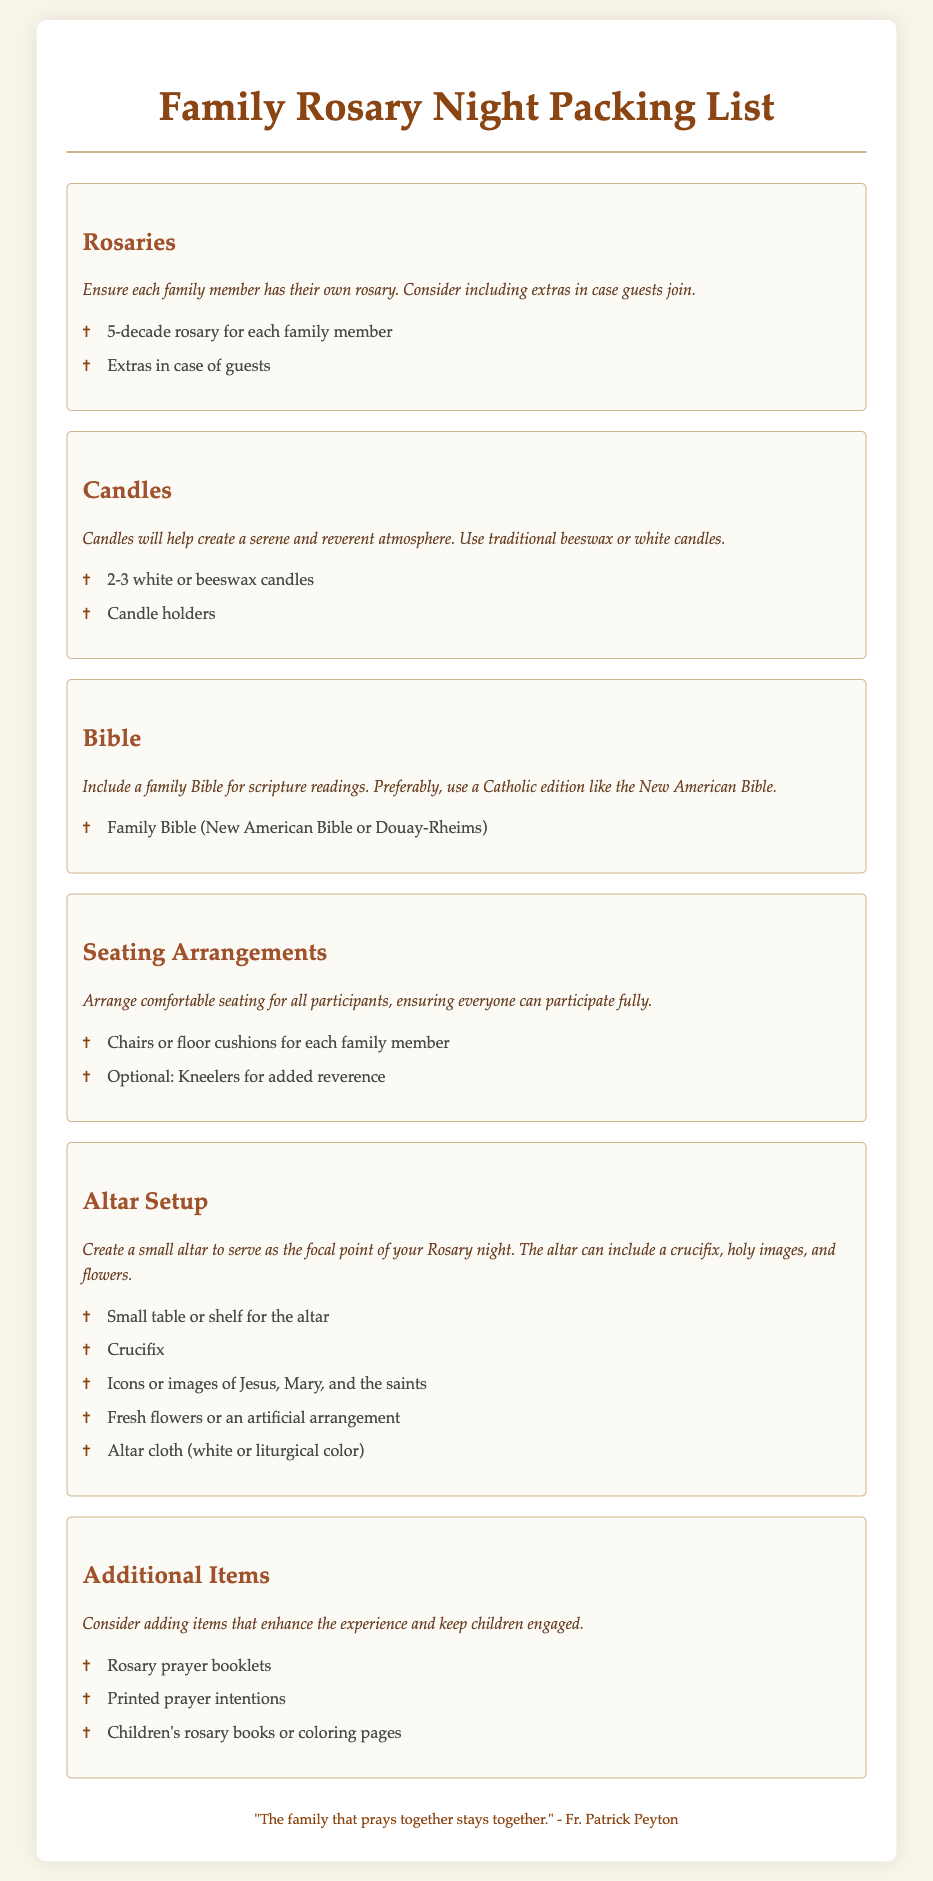What is the total number of rosaries suggested? The document recommends a 5-decade rosary for each family member and extras for guests, so the total number of rosaries would depend on the number of family members. For example, if there are 5 members, then it's 5 plus extras.
Answer: 5 How many candles should be included? It states to have 2-3 white or beeswax candles for the Rosary night.
Answer: 2-3 What type of Bible is recommended? The document specifies to use a Catholic edition for scripture readings, such as the New American Bible or Douay-Rheims.
Answer: New American Bible or Douay-Rheims What is suggested for seating arrangements? The document advises using chairs or floor cushions for each family member and optionally kneelers for added reverence.
Answer: Chairs or floor cushions What items are recommended for the altar setup? It details various items to create an altar, including a crucifix and images of Jesus, Mary, and the saints.
Answer: Crucifix, images of Jesus, Mary, and saints How many additional items are listed? The section for additional items includes three suggestions to enhance the experience.
Answer: 3 What colors are suggested for the altar cloth? The document mentions using an altar cloth of white or liturgical color.
Answer: White or liturgical color Which quote is included in the footer? The footer contains a quote about the significance of family prayer, attributed to Fr. Patrick Peyton.
Answer: "The family that prays together stays together." - Fr. Patrick Peyton 